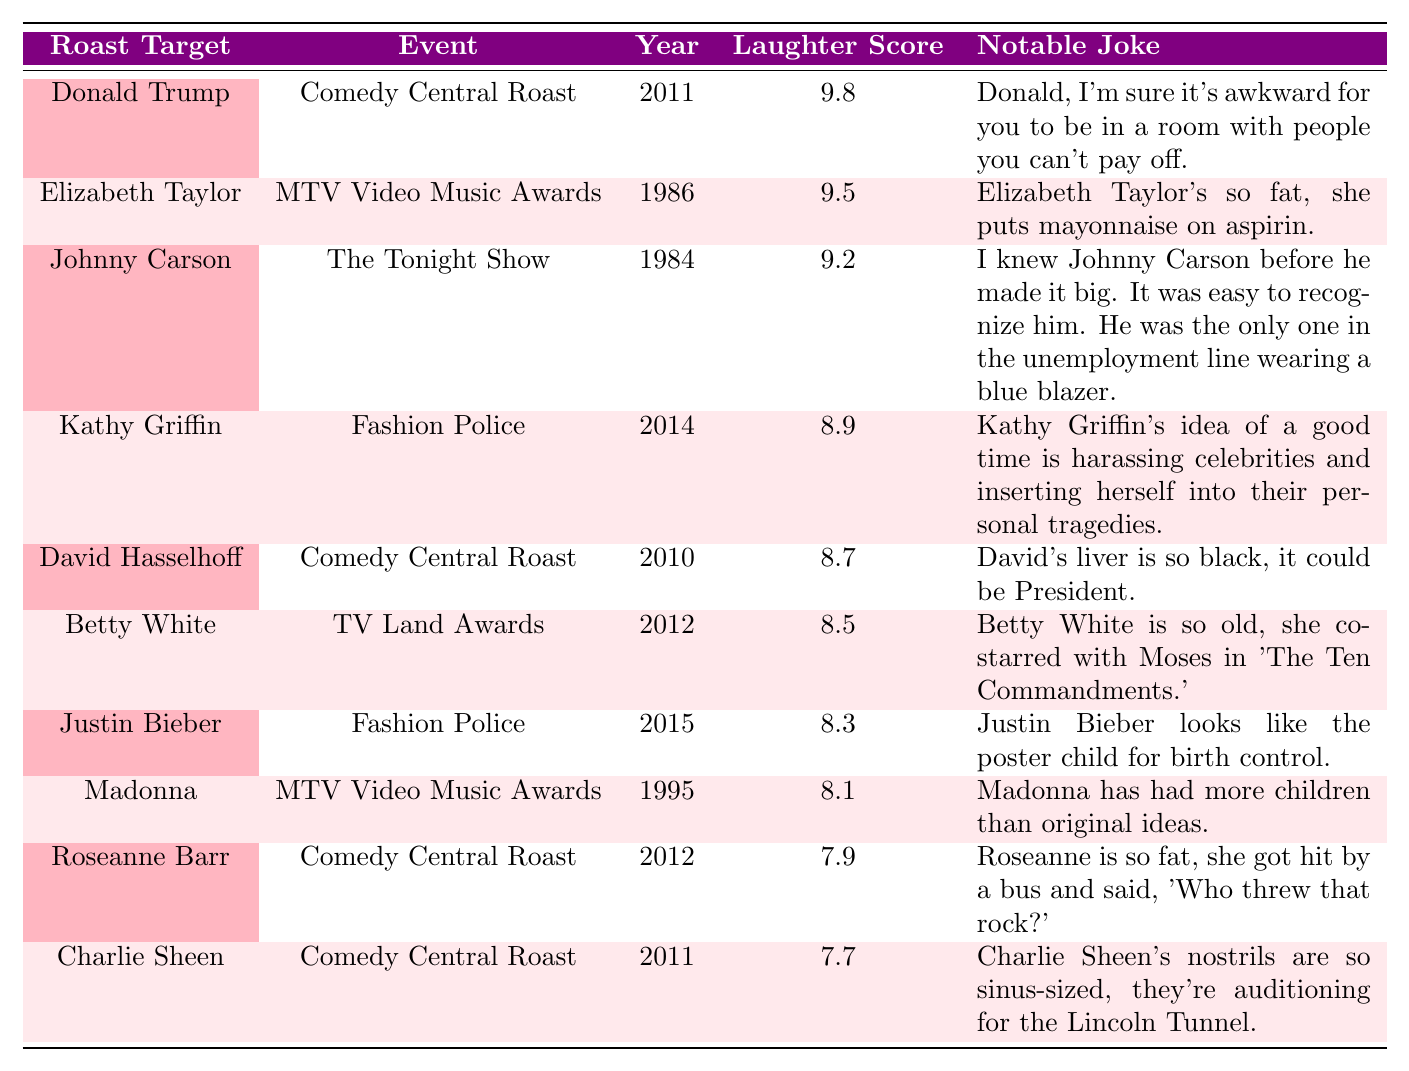What was the highest audience laughter score? The highest score in the table is 9.8 for the roast of Donald Trump in 2011.
Answer: 9.8 Who roasted Justin Bieber and what was the notable joke? Justin Bieber was roasted on Fashion Police in 2015, and the notable joke was, "Justin Bieber looks like the poster child for birth control."
Answer: Kathy Griffin, "Justin Bieber looks like the poster child for birth control." Which roast event had the oldest roast target? The roast target from the earliest year in the table is Elizabeth Taylor in 1986 during the MTV Video Music Awards.
Answer: MTV Video Music Awards What is the average audience laughter score of the roasts listed? Adding all the scores (9.8 + 9.5 + 9.2 + 8.9 + 8.7 + 8.5 + 8.3 + 8.1 + 7.9 + 7.7) gives us 88.6. There are 10 roasts, so the average is 88.6 / 10 = 8.86.
Answer: 8.86 Is the joke told about Madonna more humorous than the one told about Charlie Sheen based on their scores? Madonna received a score of 8.1 while Charlie Sheen received a score of 7.7. Since 8.1 is greater than 7.7, Madonna's joke is considered more humorous.
Answer: Yes Which roast target had a notable joke involving a historical reference? The roast of Betty White in 2012 includes a historical reference to Moses, stating, "Betty White is so old, she co-starred with Moses in 'The Ten Commandments.'"
Answer: Betty White How many roast targets received a laughter score of 8.5 or higher? The roast targets with scores of 8.5 or higher are Donald Trump, Elizabeth Taylor, Johnny Carson, Kathy Griffin, David Hasselhoff, and Betty White. Counting these, there are 6 roast targets.
Answer: 6 Which roast event had a lower audience laughter score, Comedy Central Roast or MTV Video Music Awards? The Comedy Central Roast shown in the table had two events – one for Roseanne Barr with a score of 7.9 and another for Donald Trump scoring 9.8. The MTV Video Music Awards had Elizabeth Taylor (9.5) and Madonna (8.1). The lowest overall score is Roseanne Barr's 7.9 from Comedy Central Roast.
Answer: Comedy Central Roast How does the audience laughter score for David Hasselhoff compare to that of Johnny Carson? David Hasselhoff's score is 8.7 which is higher than Johnny Carson's score of 9.2.
Answer: Lower Which roast had the least laughter score among the ones listed? The roast with the least laughter score is Charlie Sheen in 2011, which has a score of 7.7.
Answer: Charlie Sheen 